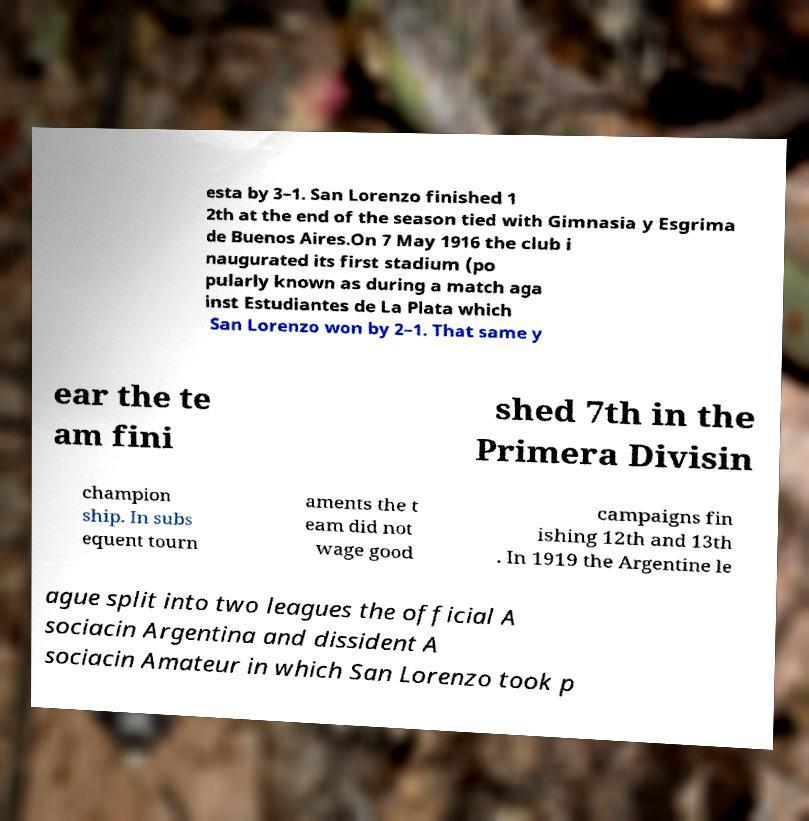Could you assist in decoding the text presented in this image and type it out clearly? esta by 3–1. San Lorenzo finished 1 2th at the end of the season tied with Gimnasia y Esgrima de Buenos Aires.On 7 May 1916 the club i naugurated its first stadium (po pularly known as during a match aga inst Estudiantes de La Plata which San Lorenzo won by 2–1. That same y ear the te am fini shed 7th in the Primera Divisin champion ship. In subs equent tourn aments the t eam did not wage good campaigns fin ishing 12th and 13th . In 1919 the Argentine le ague split into two leagues the official A sociacin Argentina and dissident A sociacin Amateur in which San Lorenzo took p 